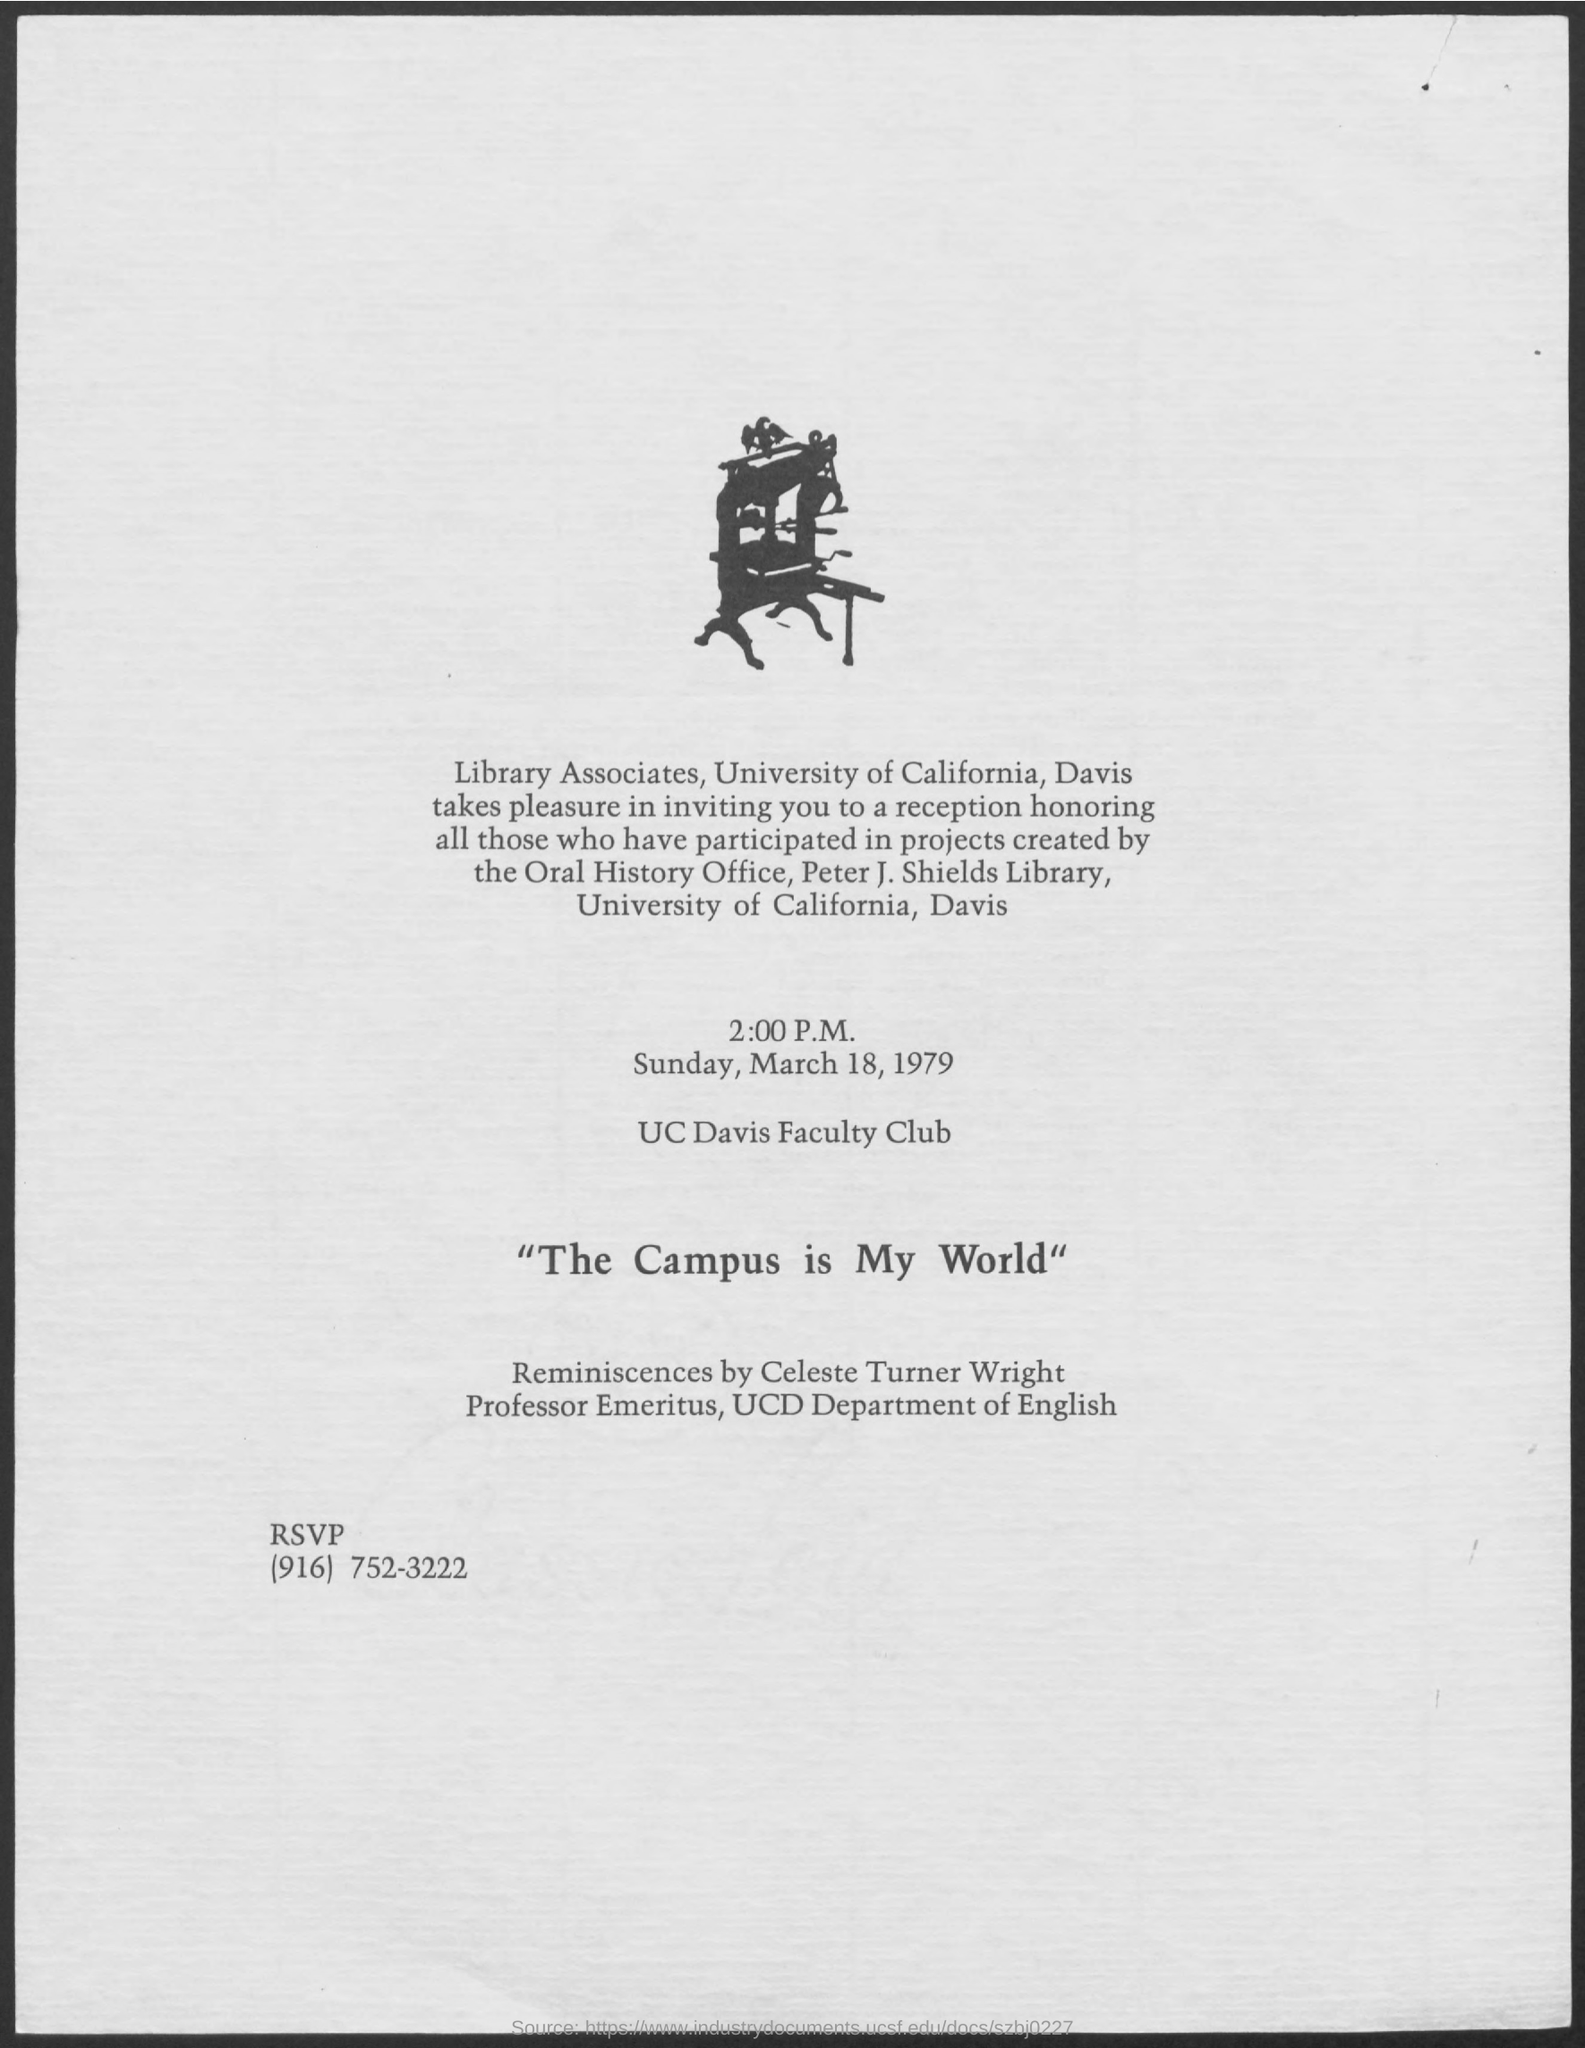What is the contact of rsvp?
Give a very brief answer. (916) 752-3222. What is the fullform of UCD?
Ensure brevity in your answer.  University of California, Davis. 